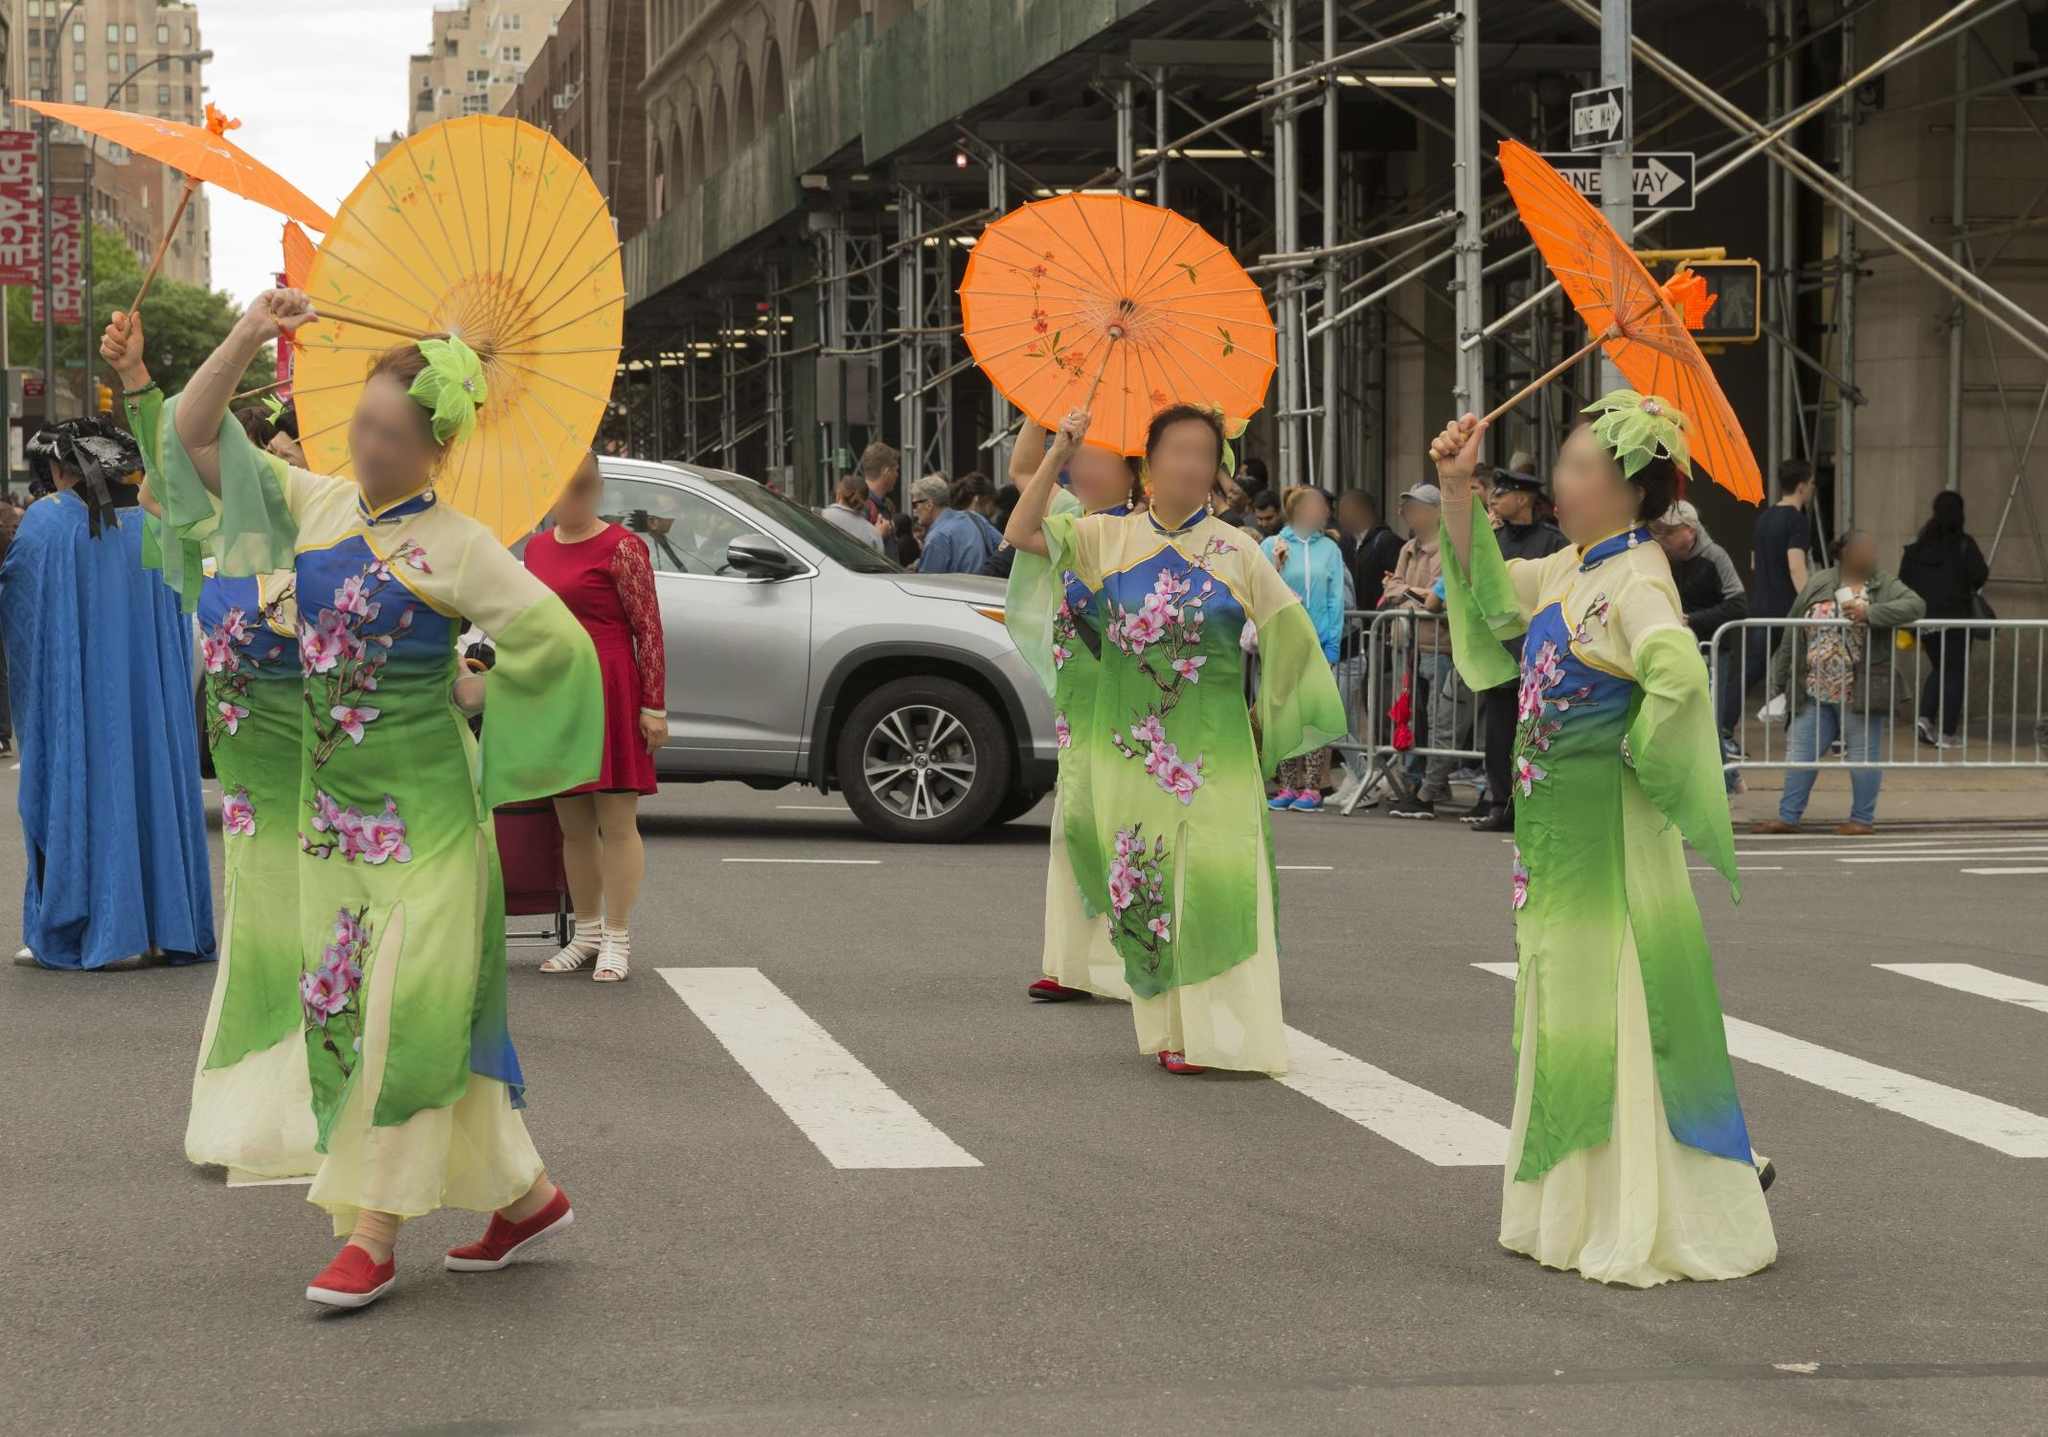Explain the visual content of the image in great detail. The image captures a lively and festive scene from a parade taking place in an urban setting. The main highlights of the image are four women dressed in vibrant traditional attire, possibly from East Asia, given the style of their outfit. They are elegantly adorned in green and ivory kimonos embellished with intricate floral patterns, predominantly in shades of purple. Each woman is holding a parasol, which comes in orange and yellow, adding a vivid splash of color to the ensemble.

Their graceful procession is set against the backdrop of a bustling city street lined with tall buildings, scaffolding, and a crowd of onlookers. The street scene includes other elements, such as a car parked and several parade viewers standing behind metal barricades, capturing the attention of the passersby. The perspective of the photo is taken from a low angle, looking up towards the women, giving them a prominent and grandiose presence. The image is highly detailed, offering a rich and colorful depiction of cultural festivities in an urban context. 